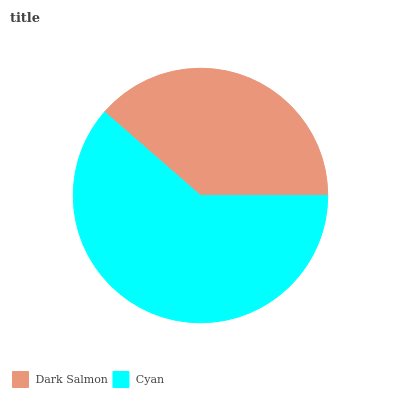Is Dark Salmon the minimum?
Answer yes or no. Yes. Is Cyan the maximum?
Answer yes or no. Yes. Is Cyan the minimum?
Answer yes or no. No. Is Cyan greater than Dark Salmon?
Answer yes or no. Yes. Is Dark Salmon less than Cyan?
Answer yes or no. Yes. Is Dark Salmon greater than Cyan?
Answer yes or no. No. Is Cyan less than Dark Salmon?
Answer yes or no. No. Is Cyan the high median?
Answer yes or no. Yes. Is Dark Salmon the low median?
Answer yes or no. Yes. Is Dark Salmon the high median?
Answer yes or no. No. Is Cyan the low median?
Answer yes or no. No. 